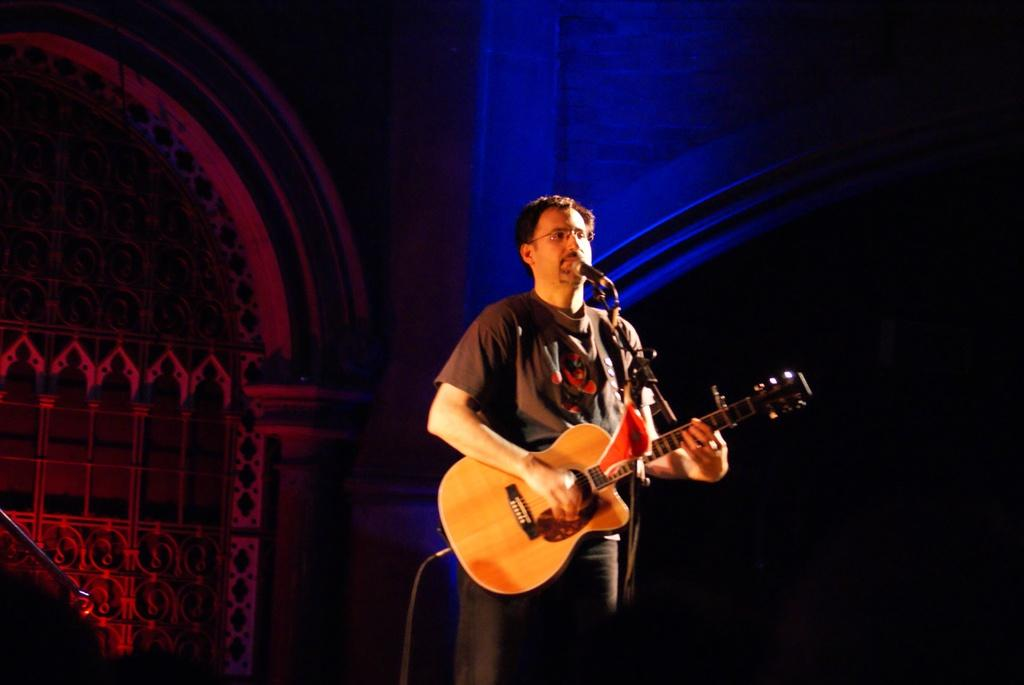What is the main subject of the image? The main subject of the image is a man. What is the man holding in his hand? The man is holding a guitar in his hand. What object is in front of the man? There is a microphone in front of the man. What type of hook can be seen hanging from the ceiling in the image? There is no hook visible in the image; it features a man holding a guitar and standing in front of a microphone. 